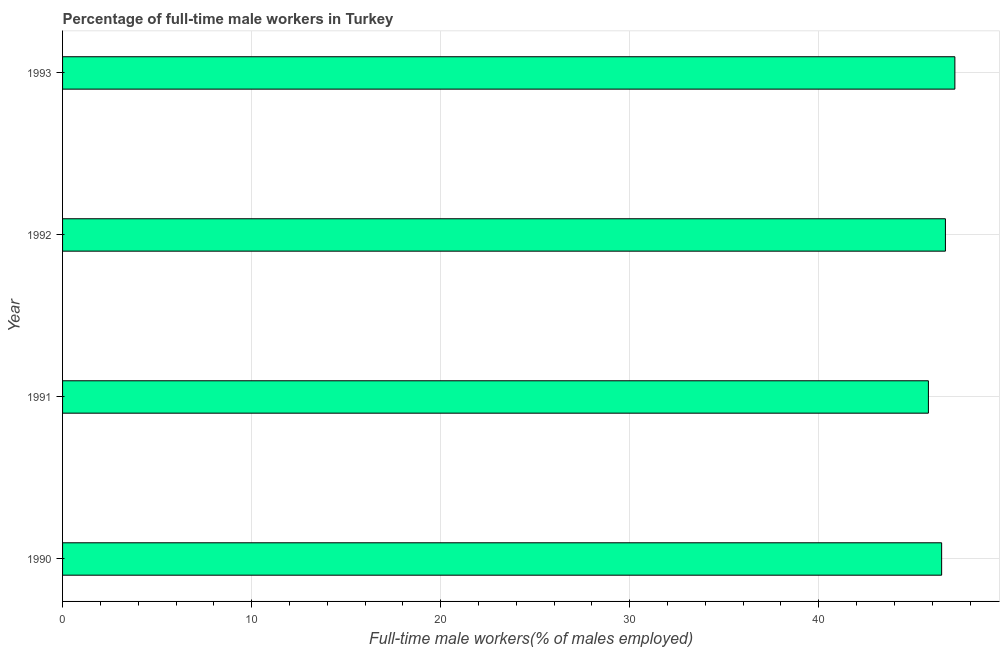Does the graph contain any zero values?
Your response must be concise. No. What is the title of the graph?
Provide a succinct answer. Percentage of full-time male workers in Turkey. What is the label or title of the X-axis?
Give a very brief answer. Full-time male workers(% of males employed). What is the percentage of full-time male workers in 1992?
Provide a succinct answer. 46.7. Across all years, what is the maximum percentage of full-time male workers?
Provide a short and direct response. 47.2. Across all years, what is the minimum percentage of full-time male workers?
Provide a short and direct response. 45.8. In which year was the percentage of full-time male workers maximum?
Make the answer very short. 1993. What is the sum of the percentage of full-time male workers?
Make the answer very short. 186.2. What is the difference between the percentage of full-time male workers in 1992 and 1993?
Ensure brevity in your answer.  -0.5. What is the average percentage of full-time male workers per year?
Your answer should be compact. 46.55. What is the median percentage of full-time male workers?
Make the answer very short. 46.6. Is the percentage of full-time male workers in 1991 less than that in 1992?
Offer a terse response. Yes. Is the difference between the percentage of full-time male workers in 1990 and 1993 greater than the difference between any two years?
Provide a succinct answer. No. What is the difference between the highest and the second highest percentage of full-time male workers?
Provide a short and direct response. 0.5. What is the difference between the highest and the lowest percentage of full-time male workers?
Your answer should be compact. 1.4. In how many years, is the percentage of full-time male workers greater than the average percentage of full-time male workers taken over all years?
Provide a succinct answer. 2. Are the values on the major ticks of X-axis written in scientific E-notation?
Offer a terse response. No. What is the Full-time male workers(% of males employed) of 1990?
Provide a short and direct response. 46.5. What is the Full-time male workers(% of males employed) in 1991?
Offer a very short reply. 45.8. What is the Full-time male workers(% of males employed) of 1992?
Keep it short and to the point. 46.7. What is the Full-time male workers(% of males employed) in 1993?
Your response must be concise. 47.2. What is the difference between the Full-time male workers(% of males employed) in 1990 and 1992?
Give a very brief answer. -0.2. What is the difference between the Full-time male workers(% of males employed) in 1991 and 1992?
Give a very brief answer. -0.9. What is the difference between the Full-time male workers(% of males employed) in 1991 and 1993?
Your answer should be very brief. -1.4. What is the ratio of the Full-time male workers(% of males employed) in 1990 to that in 1992?
Ensure brevity in your answer.  1. What is the ratio of the Full-time male workers(% of males employed) in 1990 to that in 1993?
Offer a very short reply. 0.98. What is the ratio of the Full-time male workers(% of males employed) in 1991 to that in 1992?
Provide a short and direct response. 0.98. What is the ratio of the Full-time male workers(% of males employed) in 1991 to that in 1993?
Your answer should be compact. 0.97. 